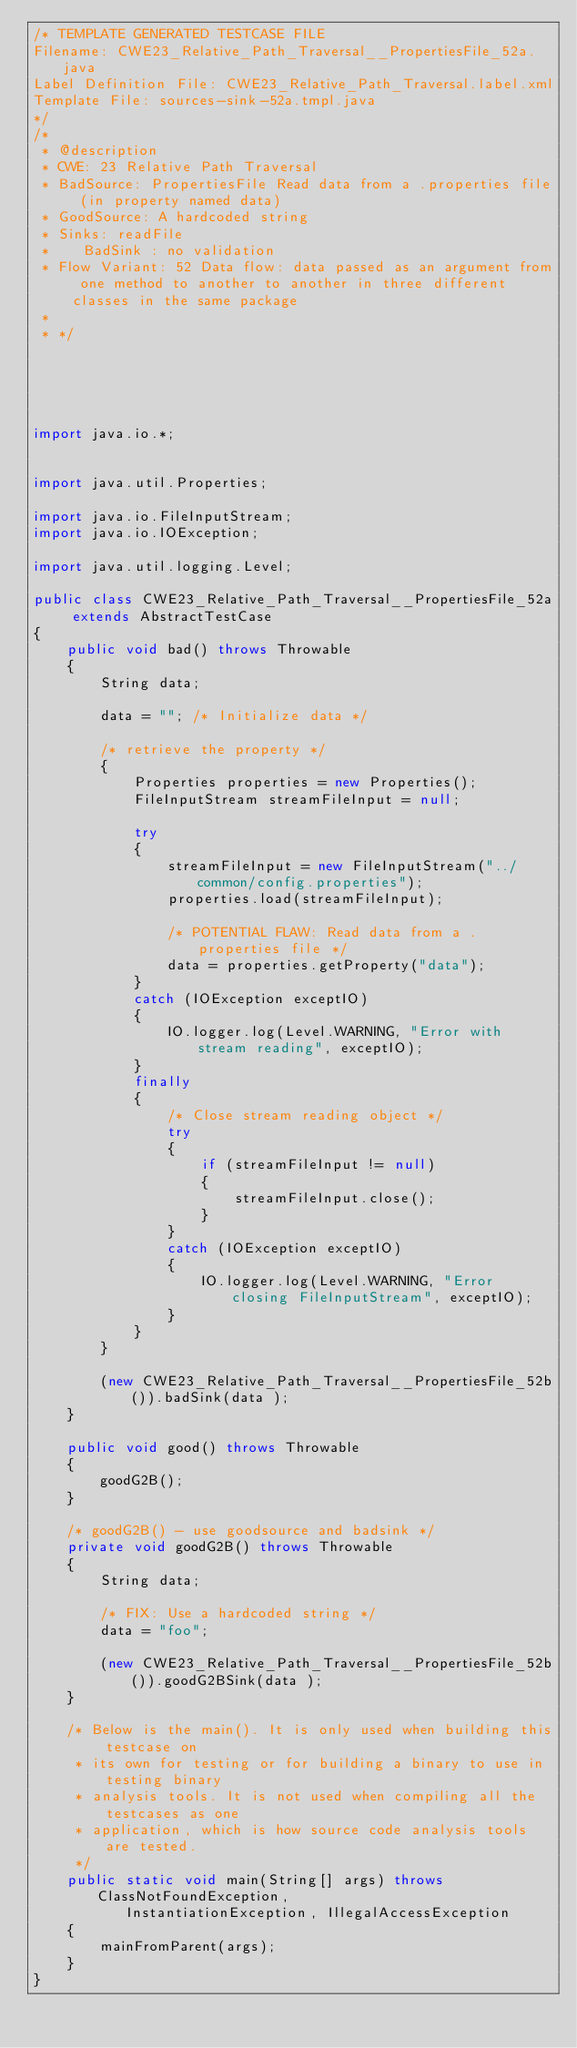Convert code to text. <code><loc_0><loc_0><loc_500><loc_500><_Java_>/* TEMPLATE GENERATED TESTCASE FILE
Filename: CWE23_Relative_Path_Traversal__PropertiesFile_52a.java
Label Definition File: CWE23_Relative_Path_Traversal.label.xml
Template File: sources-sink-52a.tmpl.java
*/
/*
 * @description
 * CWE: 23 Relative Path Traversal
 * BadSource: PropertiesFile Read data from a .properties file (in property named data)
 * GoodSource: A hardcoded string
 * Sinks: readFile
 *    BadSink : no validation
 * Flow Variant: 52 Data flow: data passed as an argument from one method to another to another in three different classes in the same package
 *
 * */





import java.io.*;


import java.util.Properties;

import java.io.FileInputStream;
import java.io.IOException;

import java.util.logging.Level;

public class CWE23_Relative_Path_Traversal__PropertiesFile_52a extends AbstractTestCase
{
    public void bad() throws Throwable
    {
        String data;

        data = ""; /* Initialize data */

        /* retrieve the property */
        {
            Properties properties = new Properties();
            FileInputStream streamFileInput = null;

            try
            {
                streamFileInput = new FileInputStream("../common/config.properties");
                properties.load(streamFileInput);

                /* POTENTIAL FLAW: Read data from a .properties file */
                data = properties.getProperty("data");
            }
            catch (IOException exceptIO)
            {
                IO.logger.log(Level.WARNING, "Error with stream reading", exceptIO);
            }
            finally
            {
                /* Close stream reading object */
                try
                {
                    if (streamFileInput != null)
                    {
                        streamFileInput.close();
                    }
                }
                catch (IOException exceptIO)
                {
                    IO.logger.log(Level.WARNING, "Error closing FileInputStream", exceptIO);
                }
            }
        }

        (new CWE23_Relative_Path_Traversal__PropertiesFile_52b()).badSink(data );
    }

    public void good() throws Throwable
    {
        goodG2B();
    }

    /* goodG2B() - use goodsource and badsink */
    private void goodG2B() throws Throwable
    {
        String data;

        /* FIX: Use a hardcoded string */
        data = "foo";

        (new CWE23_Relative_Path_Traversal__PropertiesFile_52b()).goodG2BSink(data );
    }

    /* Below is the main(). It is only used when building this testcase on
     * its own for testing or for building a binary to use in testing binary
     * analysis tools. It is not used when compiling all the testcases as one
     * application, which is how source code analysis tools are tested.
     */
    public static void main(String[] args) throws ClassNotFoundException,
           InstantiationException, IllegalAccessException
    {
        mainFromParent(args);
    }
}
</code> 